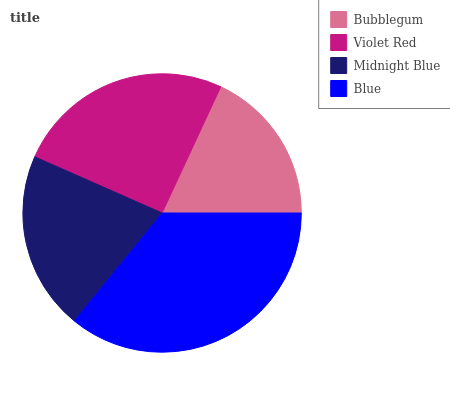Is Bubblegum the minimum?
Answer yes or no. Yes. Is Blue the maximum?
Answer yes or no. Yes. Is Violet Red the minimum?
Answer yes or no. No. Is Violet Red the maximum?
Answer yes or no. No. Is Violet Red greater than Bubblegum?
Answer yes or no. Yes. Is Bubblegum less than Violet Red?
Answer yes or no. Yes. Is Bubblegum greater than Violet Red?
Answer yes or no. No. Is Violet Red less than Bubblegum?
Answer yes or no. No. Is Violet Red the high median?
Answer yes or no. Yes. Is Midnight Blue the low median?
Answer yes or no. Yes. Is Midnight Blue the high median?
Answer yes or no. No. Is Bubblegum the low median?
Answer yes or no. No. 